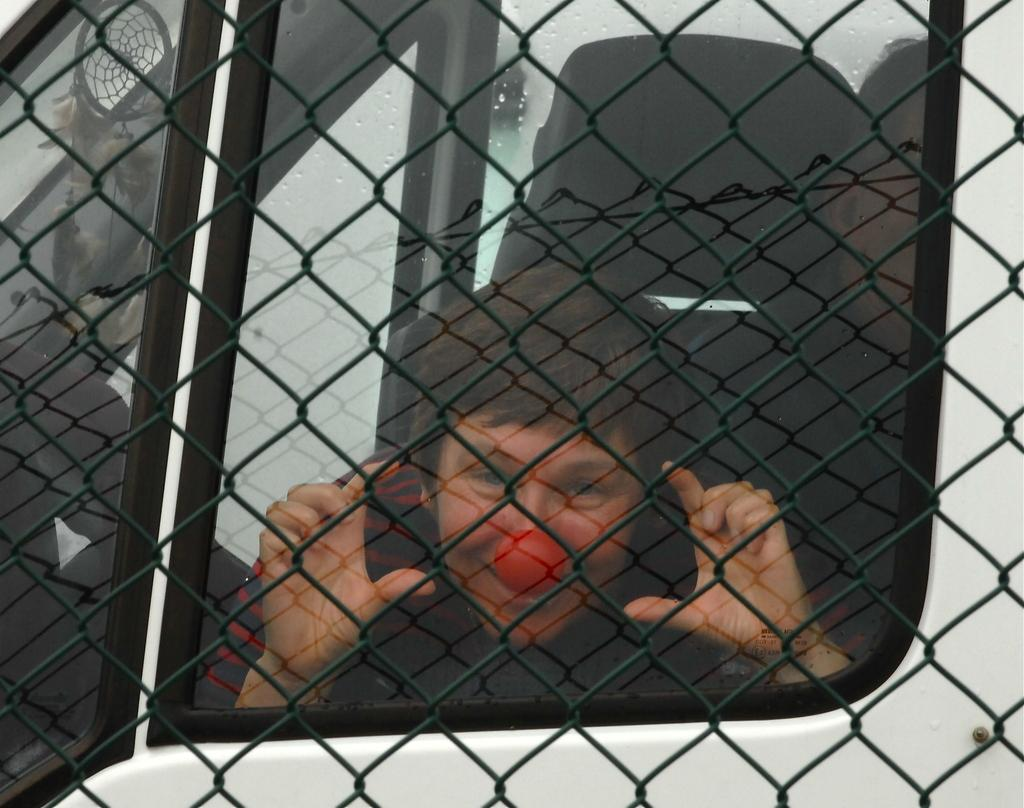What type of material is the fencing in the image made of? The fencing in the image is made of metal. What can be seen in the image besides the metal fencing? There is a white vehicle in the image. Can you describe the people inside the vehicle? There are people visible inside the vehicle through the window. What type of silk is being used to cover the butter in the image? There is no butter or silk present in the image. 